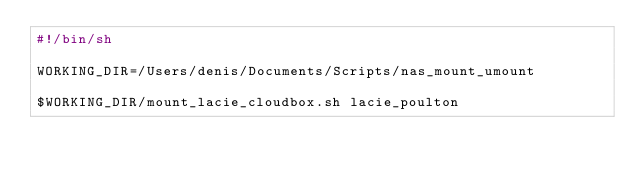<code> <loc_0><loc_0><loc_500><loc_500><_Bash_>#!/bin/sh

WORKING_DIR=/Users/denis/Documents/Scripts/nas_mount_umount

$WORKING_DIR/mount_lacie_cloudbox.sh lacie_poulton</code> 